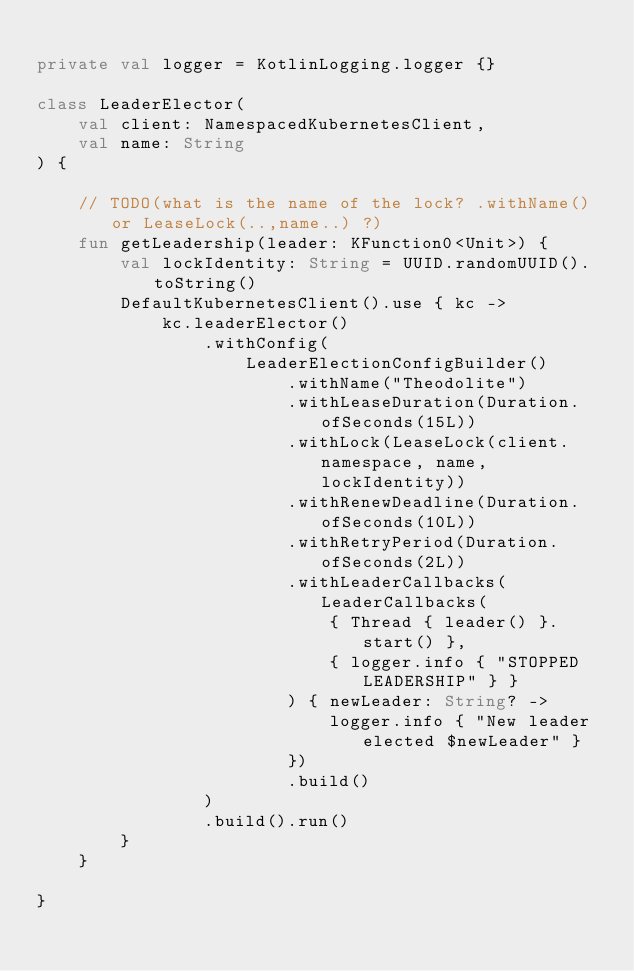<code> <loc_0><loc_0><loc_500><loc_500><_Kotlin_>
private val logger = KotlinLogging.logger {}

class LeaderElector(
    val client: NamespacedKubernetesClient,
    val name: String
) {

    // TODO(what is the name of the lock? .withName() or LeaseLock(..,name..) ?)
    fun getLeadership(leader: KFunction0<Unit>) {
        val lockIdentity: String = UUID.randomUUID().toString()
        DefaultKubernetesClient().use { kc ->
            kc.leaderElector()
                .withConfig(
                    LeaderElectionConfigBuilder()
                        .withName("Theodolite")
                        .withLeaseDuration(Duration.ofSeconds(15L))
                        .withLock(LeaseLock(client.namespace, name, lockIdentity))
                        .withRenewDeadline(Duration.ofSeconds(10L))
                        .withRetryPeriod(Duration.ofSeconds(2L))
                        .withLeaderCallbacks(LeaderCallbacks(
                            { Thread { leader() }.start() },
                            { logger.info { "STOPPED LEADERSHIP" } }
                        ) { newLeader: String? ->
                            logger.info { "New leader elected $newLeader" }
                        })
                        .build()
                )
                .build().run()
        }
    }

}</code> 